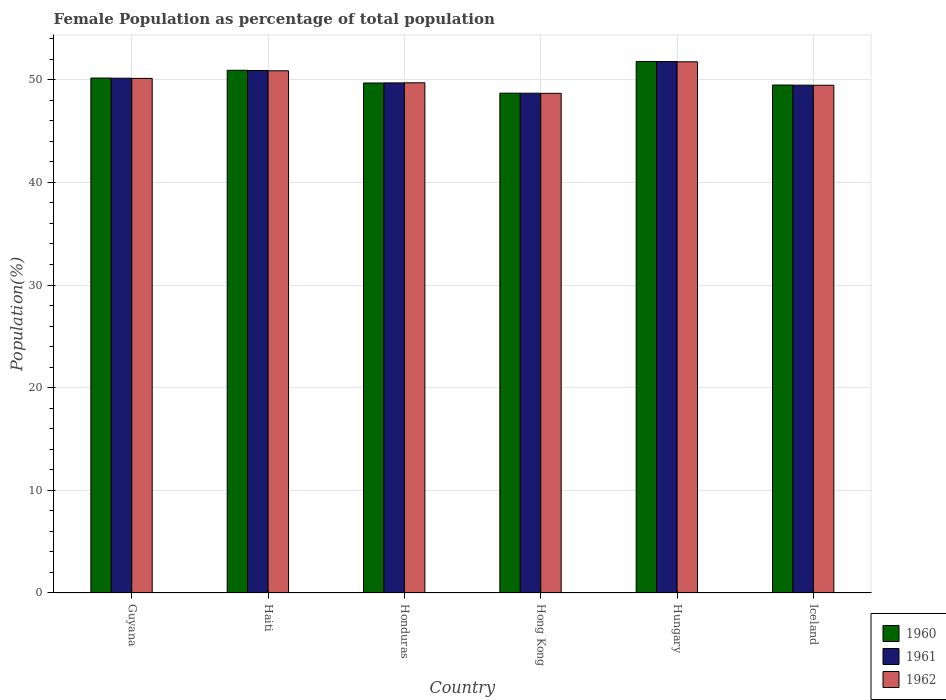How many different coloured bars are there?
Provide a short and direct response. 3. Are the number of bars per tick equal to the number of legend labels?
Make the answer very short. Yes. How many bars are there on the 6th tick from the left?
Offer a terse response. 3. What is the label of the 2nd group of bars from the left?
Offer a very short reply. Haiti. In how many cases, is the number of bars for a given country not equal to the number of legend labels?
Your response must be concise. 0. What is the female population in in 1961 in Honduras?
Offer a very short reply. 49.69. Across all countries, what is the maximum female population in in 1961?
Offer a very short reply. 51.78. Across all countries, what is the minimum female population in in 1961?
Give a very brief answer. 48.69. In which country was the female population in in 1960 maximum?
Your answer should be very brief. Hungary. In which country was the female population in in 1962 minimum?
Give a very brief answer. Hong Kong. What is the total female population in in 1961 in the graph?
Offer a terse response. 300.68. What is the difference between the female population in in 1962 in Guyana and that in Hungary?
Offer a very short reply. -1.62. What is the difference between the female population in in 1960 in Hungary and the female population in in 1961 in Honduras?
Your answer should be compact. 2.09. What is the average female population in in 1960 per country?
Ensure brevity in your answer.  50.12. What is the difference between the female population in of/in 1961 and female population in of/in 1962 in Iceland?
Offer a very short reply. 0.01. What is the ratio of the female population in in 1961 in Hong Kong to that in Hungary?
Give a very brief answer. 0.94. What is the difference between the highest and the second highest female population in in 1962?
Make the answer very short. -0.87. What is the difference between the highest and the lowest female population in in 1961?
Your answer should be compact. 3.09. In how many countries, is the female population in in 1961 greater than the average female population in in 1961 taken over all countries?
Offer a terse response. 3. What does the 2nd bar from the left in Iceland represents?
Make the answer very short. 1961. What does the 3rd bar from the right in Hong Kong represents?
Your response must be concise. 1960. Where does the legend appear in the graph?
Your answer should be very brief. Bottom right. How many legend labels are there?
Ensure brevity in your answer.  3. What is the title of the graph?
Your response must be concise. Female Population as percentage of total population. What is the label or title of the Y-axis?
Give a very brief answer. Population(%). What is the Population(%) in 1960 in Guyana?
Provide a short and direct response. 50.17. What is the Population(%) of 1961 in Guyana?
Ensure brevity in your answer.  50.15. What is the Population(%) of 1962 in Guyana?
Offer a terse response. 50.13. What is the Population(%) in 1960 in Haiti?
Make the answer very short. 50.92. What is the Population(%) in 1961 in Haiti?
Keep it short and to the point. 50.9. What is the Population(%) of 1962 in Haiti?
Your answer should be compact. 50.87. What is the Population(%) in 1960 in Honduras?
Give a very brief answer. 49.68. What is the Population(%) of 1961 in Honduras?
Provide a short and direct response. 49.69. What is the Population(%) in 1962 in Honduras?
Your answer should be compact. 49.7. What is the Population(%) of 1960 in Hong Kong?
Make the answer very short. 48.69. What is the Population(%) in 1961 in Hong Kong?
Give a very brief answer. 48.69. What is the Population(%) in 1962 in Hong Kong?
Your answer should be compact. 48.68. What is the Population(%) of 1960 in Hungary?
Ensure brevity in your answer.  51.78. What is the Population(%) in 1961 in Hungary?
Your response must be concise. 51.78. What is the Population(%) in 1962 in Hungary?
Make the answer very short. 51.75. What is the Population(%) in 1960 in Iceland?
Offer a terse response. 49.49. What is the Population(%) of 1961 in Iceland?
Your response must be concise. 49.47. What is the Population(%) of 1962 in Iceland?
Make the answer very short. 49.47. Across all countries, what is the maximum Population(%) in 1960?
Your answer should be very brief. 51.78. Across all countries, what is the maximum Population(%) of 1961?
Ensure brevity in your answer.  51.78. Across all countries, what is the maximum Population(%) in 1962?
Provide a short and direct response. 51.75. Across all countries, what is the minimum Population(%) of 1960?
Your answer should be very brief. 48.69. Across all countries, what is the minimum Population(%) in 1961?
Give a very brief answer. 48.69. Across all countries, what is the minimum Population(%) of 1962?
Give a very brief answer. 48.68. What is the total Population(%) of 1960 in the graph?
Ensure brevity in your answer.  300.73. What is the total Population(%) of 1961 in the graph?
Provide a succinct answer. 300.68. What is the total Population(%) of 1962 in the graph?
Offer a very short reply. 300.6. What is the difference between the Population(%) in 1960 in Guyana and that in Haiti?
Your answer should be very brief. -0.76. What is the difference between the Population(%) of 1961 in Guyana and that in Haiti?
Give a very brief answer. -0.75. What is the difference between the Population(%) of 1962 in Guyana and that in Haiti?
Your response must be concise. -0.74. What is the difference between the Population(%) in 1960 in Guyana and that in Honduras?
Give a very brief answer. 0.48. What is the difference between the Population(%) in 1961 in Guyana and that in Honduras?
Your response must be concise. 0.46. What is the difference between the Population(%) in 1962 in Guyana and that in Honduras?
Your answer should be compact. 0.43. What is the difference between the Population(%) in 1960 in Guyana and that in Hong Kong?
Provide a succinct answer. 1.47. What is the difference between the Population(%) in 1961 in Guyana and that in Hong Kong?
Your answer should be very brief. 1.46. What is the difference between the Population(%) in 1962 in Guyana and that in Hong Kong?
Offer a very short reply. 1.46. What is the difference between the Population(%) of 1960 in Guyana and that in Hungary?
Your response must be concise. -1.62. What is the difference between the Population(%) of 1961 in Guyana and that in Hungary?
Make the answer very short. -1.63. What is the difference between the Population(%) of 1962 in Guyana and that in Hungary?
Provide a short and direct response. -1.62. What is the difference between the Population(%) in 1960 in Guyana and that in Iceland?
Your response must be concise. 0.68. What is the difference between the Population(%) of 1961 in Guyana and that in Iceland?
Keep it short and to the point. 0.68. What is the difference between the Population(%) in 1962 in Guyana and that in Iceland?
Give a very brief answer. 0.67. What is the difference between the Population(%) of 1960 in Haiti and that in Honduras?
Keep it short and to the point. 1.24. What is the difference between the Population(%) in 1961 in Haiti and that in Honduras?
Keep it short and to the point. 1.2. What is the difference between the Population(%) in 1962 in Haiti and that in Honduras?
Ensure brevity in your answer.  1.17. What is the difference between the Population(%) in 1960 in Haiti and that in Hong Kong?
Keep it short and to the point. 2.23. What is the difference between the Population(%) of 1961 in Haiti and that in Hong Kong?
Provide a succinct answer. 2.21. What is the difference between the Population(%) of 1962 in Haiti and that in Hong Kong?
Your answer should be very brief. 2.2. What is the difference between the Population(%) in 1960 in Haiti and that in Hungary?
Provide a short and direct response. -0.86. What is the difference between the Population(%) of 1961 in Haiti and that in Hungary?
Keep it short and to the point. -0.88. What is the difference between the Population(%) of 1962 in Haiti and that in Hungary?
Your answer should be very brief. -0.87. What is the difference between the Population(%) in 1960 in Haiti and that in Iceland?
Ensure brevity in your answer.  1.44. What is the difference between the Population(%) of 1961 in Haiti and that in Iceland?
Give a very brief answer. 1.42. What is the difference between the Population(%) of 1962 in Haiti and that in Iceland?
Your answer should be very brief. 1.41. What is the difference between the Population(%) of 1961 in Honduras and that in Hong Kong?
Offer a very short reply. 1. What is the difference between the Population(%) of 1962 in Honduras and that in Hong Kong?
Make the answer very short. 1.03. What is the difference between the Population(%) in 1960 in Honduras and that in Hungary?
Offer a very short reply. -2.1. What is the difference between the Population(%) of 1961 in Honduras and that in Hungary?
Offer a very short reply. -2.08. What is the difference between the Population(%) of 1962 in Honduras and that in Hungary?
Provide a short and direct response. -2.05. What is the difference between the Population(%) in 1960 in Honduras and that in Iceland?
Provide a short and direct response. 0.2. What is the difference between the Population(%) of 1961 in Honduras and that in Iceland?
Offer a very short reply. 0.22. What is the difference between the Population(%) of 1962 in Honduras and that in Iceland?
Your response must be concise. 0.24. What is the difference between the Population(%) of 1960 in Hong Kong and that in Hungary?
Offer a very short reply. -3.09. What is the difference between the Population(%) of 1961 in Hong Kong and that in Hungary?
Offer a terse response. -3.09. What is the difference between the Population(%) in 1962 in Hong Kong and that in Hungary?
Ensure brevity in your answer.  -3.07. What is the difference between the Population(%) of 1960 in Hong Kong and that in Iceland?
Make the answer very short. -0.79. What is the difference between the Population(%) of 1961 in Hong Kong and that in Iceland?
Your answer should be compact. -0.78. What is the difference between the Population(%) of 1962 in Hong Kong and that in Iceland?
Offer a very short reply. -0.79. What is the difference between the Population(%) in 1960 in Hungary and that in Iceland?
Keep it short and to the point. 2.3. What is the difference between the Population(%) in 1961 in Hungary and that in Iceland?
Give a very brief answer. 2.3. What is the difference between the Population(%) in 1962 in Hungary and that in Iceland?
Provide a short and direct response. 2.28. What is the difference between the Population(%) in 1960 in Guyana and the Population(%) in 1961 in Haiti?
Offer a terse response. -0.73. What is the difference between the Population(%) of 1960 in Guyana and the Population(%) of 1962 in Haiti?
Offer a very short reply. -0.71. What is the difference between the Population(%) of 1961 in Guyana and the Population(%) of 1962 in Haiti?
Ensure brevity in your answer.  -0.72. What is the difference between the Population(%) of 1960 in Guyana and the Population(%) of 1961 in Honduras?
Your response must be concise. 0.47. What is the difference between the Population(%) of 1960 in Guyana and the Population(%) of 1962 in Honduras?
Make the answer very short. 0.46. What is the difference between the Population(%) of 1961 in Guyana and the Population(%) of 1962 in Honduras?
Your response must be concise. 0.45. What is the difference between the Population(%) in 1960 in Guyana and the Population(%) in 1961 in Hong Kong?
Give a very brief answer. 1.48. What is the difference between the Population(%) in 1960 in Guyana and the Population(%) in 1962 in Hong Kong?
Your answer should be compact. 1.49. What is the difference between the Population(%) in 1961 in Guyana and the Population(%) in 1962 in Hong Kong?
Your answer should be very brief. 1.47. What is the difference between the Population(%) of 1960 in Guyana and the Population(%) of 1961 in Hungary?
Ensure brevity in your answer.  -1.61. What is the difference between the Population(%) in 1960 in Guyana and the Population(%) in 1962 in Hungary?
Provide a short and direct response. -1.58. What is the difference between the Population(%) in 1961 in Guyana and the Population(%) in 1962 in Hungary?
Keep it short and to the point. -1.6. What is the difference between the Population(%) of 1960 in Guyana and the Population(%) of 1961 in Iceland?
Keep it short and to the point. 0.69. What is the difference between the Population(%) in 1960 in Guyana and the Population(%) in 1962 in Iceland?
Provide a short and direct response. 0.7. What is the difference between the Population(%) in 1961 in Guyana and the Population(%) in 1962 in Iceland?
Your response must be concise. 0.68. What is the difference between the Population(%) of 1960 in Haiti and the Population(%) of 1961 in Honduras?
Give a very brief answer. 1.23. What is the difference between the Population(%) of 1960 in Haiti and the Population(%) of 1962 in Honduras?
Your response must be concise. 1.22. What is the difference between the Population(%) in 1961 in Haiti and the Population(%) in 1962 in Honduras?
Provide a short and direct response. 1.19. What is the difference between the Population(%) in 1960 in Haiti and the Population(%) in 1961 in Hong Kong?
Your answer should be very brief. 2.23. What is the difference between the Population(%) in 1960 in Haiti and the Population(%) in 1962 in Hong Kong?
Keep it short and to the point. 2.25. What is the difference between the Population(%) of 1961 in Haiti and the Population(%) of 1962 in Hong Kong?
Your response must be concise. 2.22. What is the difference between the Population(%) in 1960 in Haiti and the Population(%) in 1961 in Hungary?
Provide a succinct answer. -0.85. What is the difference between the Population(%) in 1960 in Haiti and the Population(%) in 1962 in Hungary?
Offer a terse response. -0.83. What is the difference between the Population(%) of 1961 in Haiti and the Population(%) of 1962 in Hungary?
Provide a short and direct response. -0.85. What is the difference between the Population(%) in 1960 in Haiti and the Population(%) in 1961 in Iceland?
Give a very brief answer. 1.45. What is the difference between the Population(%) of 1960 in Haiti and the Population(%) of 1962 in Iceland?
Keep it short and to the point. 1.46. What is the difference between the Population(%) in 1961 in Haiti and the Population(%) in 1962 in Iceland?
Ensure brevity in your answer.  1.43. What is the difference between the Population(%) in 1960 in Honduras and the Population(%) in 1962 in Hong Kong?
Your response must be concise. 1.01. What is the difference between the Population(%) of 1961 in Honduras and the Population(%) of 1962 in Hong Kong?
Provide a short and direct response. 1.02. What is the difference between the Population(%) in 1960 in Honduras and the Population(%) in 1961 in Hungary?
Your answer should be very brief. -2.09. What is the difference between the Population(%) in 1960 in Honduras and the Population(%) in 1962 in Hungary?
Your answer should be very brief. -2.06. What is the difference between the Population(%) in 1961 in Honduras and the Population(%) in 1962 in Hungary?
Give a very brief answer. -2.06. What is the difference between the Population(%) in 1960 in Honduras and the Population(%) in 1961 in Iceland?
Offer a very short reply. 0.21. What is the difference between the Population(%) of 1960 in Honduras and the Population(%) of 1962 in Iceland?
Give a very brief answer. 0.22. What is the difference between the Population(%) in 1961 in Honduras and the Population(%) in 1962 in Iceland?
Make the answer very short. 0.23. What is the difference between the Population(%) of 1960 in Hong Kong and the Population(%) of 1961 in Hungary?
Provide a succinct answer. -3.08. What is the difference between the Population(%) in 1960 in Hong Kong and the Population(%) in 1962 in Hungary?
Ensure brevity in your answer.  -3.05. What is the difference between the Population(%) in 1961 in Hong Kong and the Population(%) in 1962 in Hungary?
Ensure brevity in your answer.  -3.06. What is the difference between the Population(%) in 1960 in Hong Kong and the Population(%) in 1961 in Iceland?
Provide a succinct answer. -0.78. What is the difference between the Population(%) in 1960 in Hong Kong and the Population(%) in 1962 in Iceland?
Make the answer very short. -0.77. What is the difference between the Population(%) in 1961 in Hong Kong and the Population(%) in 1962 in Iceland?
Ensure brevity in your answer.  -0.78. What is the difference between the Population(%) in 1960 in Hungary and the Population(%) in 1961 in Iceland?
Ensure brevity in your answer.  2.31. What is the difference between the Population(%) in 1960 in Hungary and the Population(%) in 1962 in Iceland?
Keep it short and to the point. 2.32. What is the difference between the Population(%) of 1961 in Hungary and the Population(%) of 1962 in Iceland?
Provide a short and direct response. 2.31. What is the average Population(%) of 1960 per country?
Make the answer very short. 50.12. What is the average Population(%) of 1961 per country?
Give a very brief answer. 50.11. What is the average Population(%) in 1962 per country?
Your answer should be compact. 50.1. What is the difference between the Population(%) of 1960 and Population(%) of 1961 in Guyana?
Give a very brief answer. 0.02. What is the difference between the Population(%) of 1960 and Population(%) of 1962 in Guyana?
Make the answer very short. 0.03. What is the difference between the Population(%) in 1961 and Population(%) in 1962 in Guyana?
Keep it short and to the point. 0.02. What is the difference between the Population(%) in 1960 and Population(%) in 1961 in Haiti?
Your answer should be very brief. 0.02. What is the difference between the Population(%) of 1960 and Population(%) of 1962 in Haiti?
Ensure brevity in your answer.  0.05. What is the difference between the Population(%) in 1961 and Population(%) in 1962 in Haiti?
Offer a terse response. 0.02. What is the difference between the Population(%) in 1960 and Population(%) in 1961 in Honduras?
Keep it short and to the point. -0.01. What is the difference between the Population(%) in 1960 and Population(%) in 1962 in Honduras?
Ensure brevity in your answer.  -0.02. What is the difference between the Population(%) of 1961 and Population(%) of 1962 in Honduras?
Your answer should be very brief. -0.01. What is the difference between the Population(%) in 1960 and Population(%) in 1961 in Hong Kong?
Provide a succinct answer. 0.01. What is the difference between the Population(%) of 1960 and Population(%) of 1962 in Hong Kong?
Your response must be concise. 0.02. What is the difference between the Population(%) of 1961 and Population(%) of 1962 in Hong Kong?
Offer a terse response. 0.01. What is the difference between the Population(%) in 1960 and Population(%) in 1961 in Hungary?
Make the answer very short. 0.01. What is the difference between the Population(%) in 1960 and Population(%) in 1962 in Hungary?
Your answer should be compact. 0.03. What is the difference between the Population(%) of 1961 and Population(%) of 1962 in Hungary?
Give a very brief answer. 0.03. What is the difference between the Population(%) in 1960 and Population(%) in 1961 in Iceland?
Offer a terse response. 0.01. What is the difference between the Population(%) in 1960 and Population(%) in 1962 in Iceland?
Ensure brevity in your answer.  0.02. What is the difference between the Population(%) in 1961 and Population(%) in 1962 in Iceland?
Your answer should be very brief. 0.01. What is the ratio of the Population(%) in 1960 in Guyana to that in Haiti?
Keep it short and to the point. 0.99. What is the ratio of the Population(%) in 1961 in Guyana to that in Haiti?
Give a very brief answer. 0.99. What is the ratio of the Population(%) of 1962 in Guyana to that in Haiti?
Provide a succinct answer. 0.99. What is the ratio of the Population(%) of 1960 in Guyana to that in Honduras?
Make the answer very short. 1.01. What is the ratio of the Population(%) of 1961 in Guyana to that in Honduras?
Offer a very short reply. 1.01. What is the ratio of the Population(%) in 1962 in Guyana to that in Honduras?
Your answer should be very brief. 1.01. What is the ratio of the Population(%) of 1960 in Guyana to that in Hong Kong?
Give a very brief answer. 1.03. What is the ratio of the Population(%) of 1962 in Guyana to that in Hong Kong?
Your response must be concise. 1.03. What is the ratio of the Population(%) in 1960 in Guyana to that in Hungary?
Keep it short and to the point. 0.97. What is the ratio of the Population(%) of 1961 in Guyana to that in Hungary?
Offer a terse response. 0.97. What is the ratio of the Population(%) of 1962 in Guyana to that in Hungary?
Keep it short and to the point. 0.97. What is the ratio of the Population(%) of 1960 in Guyana to that in Iceland?
Offer a very short reply. 1.01. What is the ratio of the Population(%) in 1961 in Guyana to that in Iceland?
Ensure brevity in your answer.  1.01. What is the ratio of the Population(%) of 1962 in Guyana to that in Iceland?
Keep it short and to the point. 1.01. What is the ratio of the Population(%) in 1960 in Haiti to that in Honduras?
Offer a terse response. 1.02. What is the ratio of the Population(%) in 1961 in Haiti to that in Honduras?
Your response must be concise. 1.02. What is the ratio of the Population(%) of 1962 in Haiti to that in Honduras?
Offer a terse response. 1.02. What is the ratio of the Population(%) of 1960 in Haiti to that in Hong Kong?
Offer a terse response. 1.05. What is the ratio of the Population(%) of 1961 in Haiti to that in Hong Kong?
Ensure brevity in your answer.  1.05. What is the ratio of the Population(%) of 1962 in Haiti to that in Hong Kong?
Your answer should be very brief. 1.05. What is the ratio of the Population(%) in 1960 in Haiti to that in Hungary?
Provide a short and direct response. 0.98. What is the ratio of the Population(%) in 1961 in Haiti to that in Hungary?
Offer a very short reply. 0.98. What is the ratio of the Population(%) in 1962 in Haiti to that in Hungary?
Give a very brief answer. 0.98. What is the ratio of the Population(%) of 1960 in Haiti to that in Iceland?
Ensure brevity in your answer.  1.03. What is the ratio of the Population(%) of 1961 in Haiti to that in Iceland?
Offer a very short reply. 1.03. What is the ratio of the Population(%) of 1962 in Haiti to that in Iceland?
Provide a short and direct response. 1.03. What is the ratio of the Population(%) in 1960 in Honduras to that in Hong Kong?
Your answer should be compact. 1.02. What is the ratio of the Population(%) in 1961 in Honduras to that in Hong Kong?
Make the answer very short. 1.02. What is the ratio of the Population(%) of 1962 in Honduras to that in Hong Kong?
Make the answer very short. 1.02. What is the ratio of the Population(%) of 1960 in Honduras to that in Hungary?
Your response must be concise. 0.96. What is the ratio of the Population(%) in 1961 in Honduras to that in Hungary?
Keep it short and to the point. 0.96. What is the ratio of the Population(%) of 1962 in Honduras to that in Hungary?
Provide a succinct answer. 0.96. What is the ratio of the Population(%) of 1961 in Honduras to that in Iceland?
Offer a terse response. 1. What is the ratio of the Population(%) in 1962 in Honduras to that in Iceland?
Ensure brevity in your answer.  1. What is the ratio of the Population(%) of 1960 in Hong Kong to that in Hungary?
Your response must be concise. 0.94. What is the ratio of the Population(%) of 1961 in Hong Kong to that in Hungary?
Make the answer very short. 0.94. What is the ratio of the Population(%) of 1962 in Hong Kong to that in Hungary?
Your answer should be compact. 0.94. What is the ratio of the Population(%) in 1960 in Hong Kong to that in Iceland?
Make the answer very short. 0.98. What is the ratio of the Population(%) of 1961 in Hong Kong to that in Iceland?
Your answer should be compact. 0.98. What is the ratio of the Population(%) of 1962 in Hong Kong to that in Iceland?
Provide a succinct answer. 0.98. What is the ratio of the Population(%) of 1960 in Hungary to that in Iceland?
Provide a short and direct response. 1.05. What is the ratio of the Population(%) of 1961 in Hungary to that in Iceland?
Offer a very short reply. 1.05. What is the ratio of the Population(%) in 1962 in Hungary to that in Iceland?
Provide a succinct answer. 1.05. What is the difference between the highest and the second highest Population(%) in 1960?
Your answer should be compact. 0.86. What is the difference between the highest and the second highest Population(%) of 1961?
Your answer should be very brief. 0.88. What is the difference between the highest and the second highest Population(%) in 1962?
Give a very brief answer. 0.87. What is the difference between the highest and the lowest Population(%) of 1960?
Your answer should be very brief. 3.09. What is the difference between the highest and the lowest Population(%) in 1961?
Keep it short and to the point. 3.09. What is the difference between the highest and the lowest Population(%) of 1962?
Make the answer very short. 3.07. 